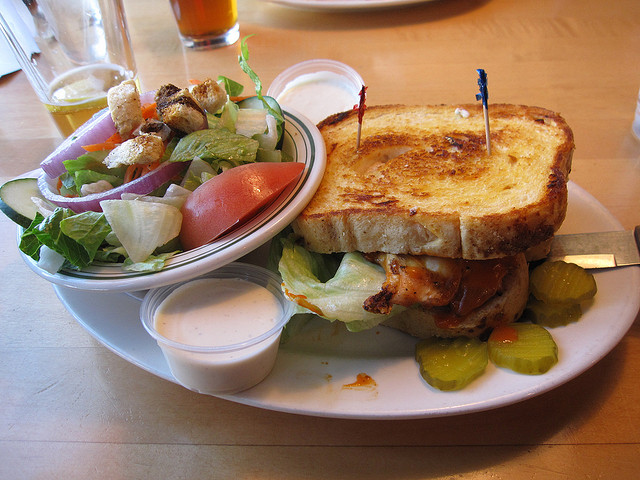Is there any specific dining style represented in this meal? This meal represents a casual American dining style, focusing on comfort foods like a hearty sandwich and a simple side salad. It's typical of what one might expect in a family restaurant or a pub, emphasizing satisfying, familiar flavors and generous portions. 